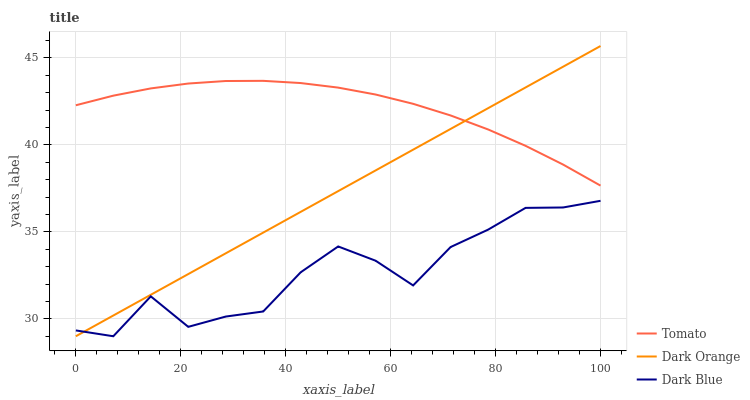Does Dark Blue have the minimum area under the curve?
Answer yes or no. Yes. Does Tomato have the maximum area under the curve?
Answer yes or no. Yes. Does Dark Orange have the minimum area under the curve?
Answer yes or no. No. Does Dark Orange have the maximum area under the curve?
Answer yes or no. No. Is Dark Orange the smoothest?
Answer yes or no. Yes. Is Dark Blue the roughest?
Answer yes or no. Yes. Is Dark Blue the smoothest?
Answer yes or no. No. Is Dark Orange the roughest?
Answer yes or no. No. Does Dark Orange have the lowest value?
Answer yes or no. Yes. Does Dark Orange have the highest value?
Answer yes or no. Yes. Does Dark Blue have the highest value?
Answer yes or no. No. Is Dark Blue less than Tomato?
Answer yes or no. Yes. Is Tomato greater than Dark Blue?
Answer yes or no. Yes. Does Tomato intersect Dark Orange?
Answer yes or no. Yes. Is Tomato less than Dark Orange?
Answer yes or no. No. Is Tomato greater than Dark Orange?
Answer yes or no. No. Does Dark Blue intersect Tomato?
Answer yes or no. No. 